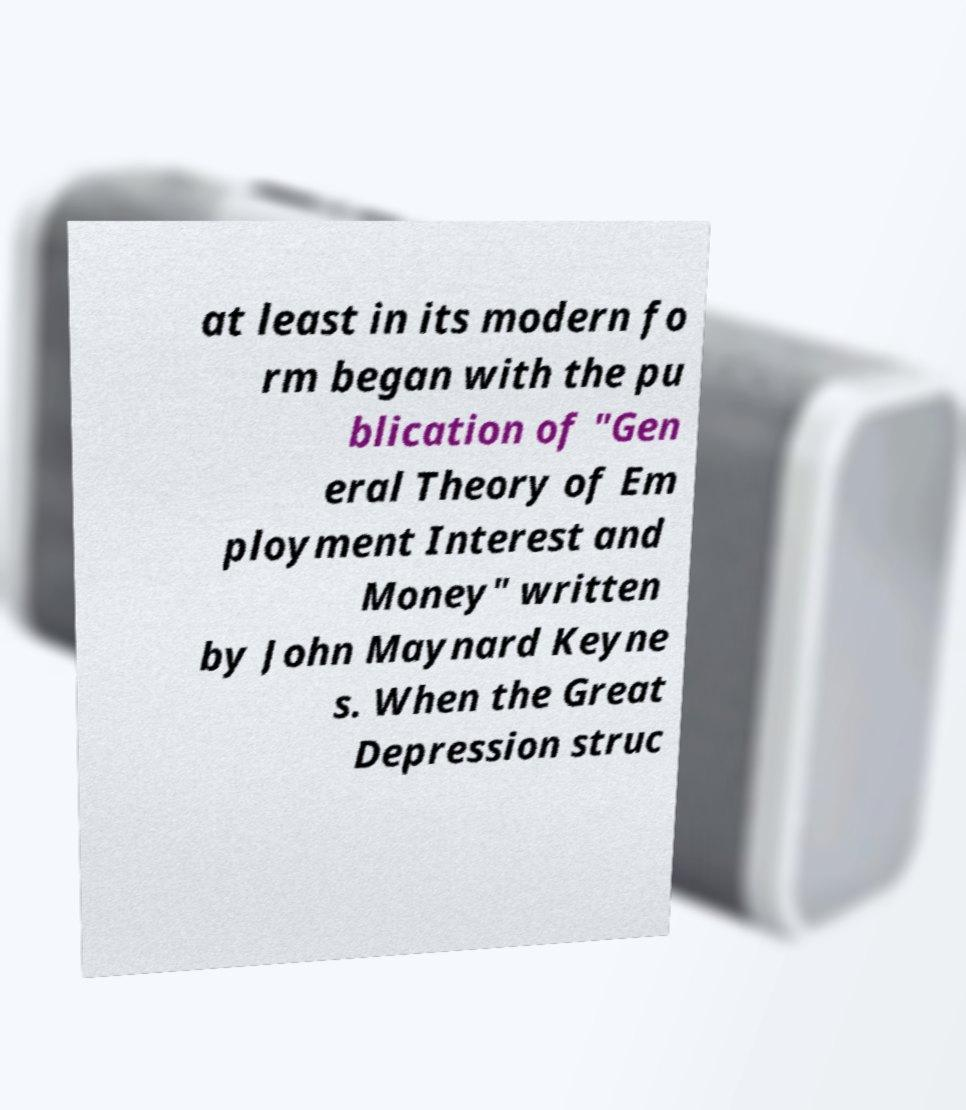Could you assist in decoding the text presented in this image and type it out clearly? at least in its modern fo rm began with the pu blication of "Gen eral Theory of Em ployment Interest and Money" written by John Maynard Keyne s. When the Great Depression struc 